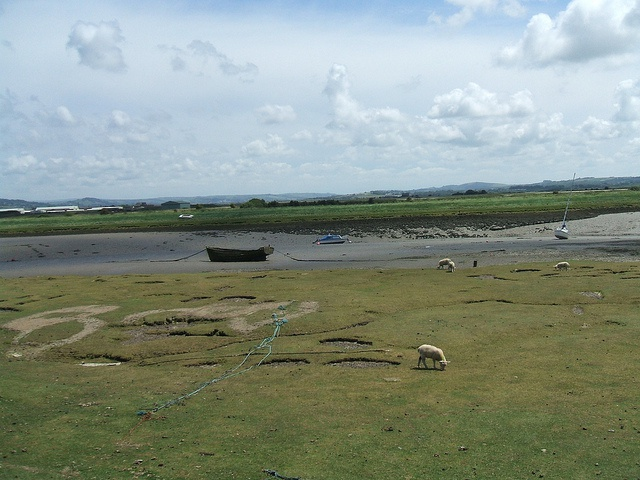Describe the objects in this image and their specific colors. I can see boat in lightblue, black, and gray tones, sheep in lightblue, black, gray, tan, and darkgreen tones, boat in lightblue, gray, black, and darkgray tones, boat in lightblue, gray, blue, black, and navy tones, and sheep in lightblue, black, gray, and darkgray tones in this image. 